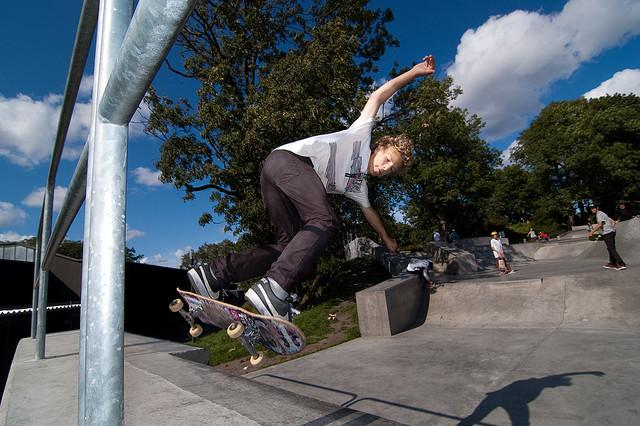What will happen to the boy next?

Choices:
A) falling off
B) lying down
C) landing
D) flipping landing 